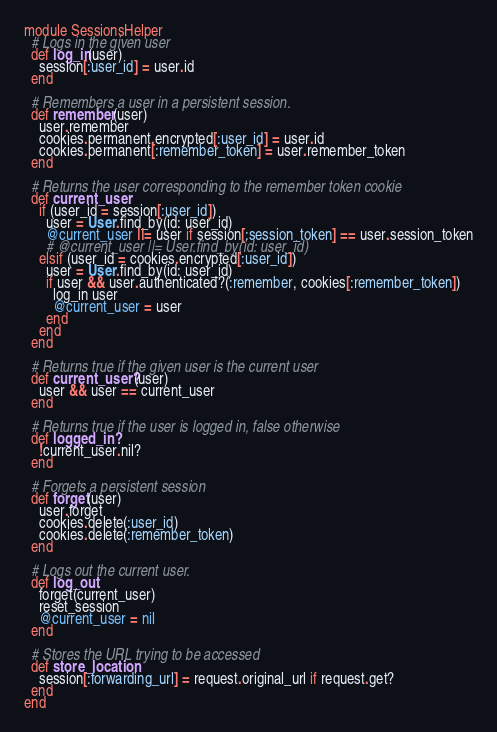<code> <loc_0><loc_0><loc_500><loc_500><_Ruby_>module SessionsHelper
  # Logs in the given user
  def log_in(user)
    session[:user_id] = user.id
  end

  # Remembers a user in a persistent session.
  def remember(user)
    user.remember
    cookies.permanent.encrypted[:user_id] = user.id
    cookies.permanent[:remember_token] = user.remember_token
  end
  
  # Returns the user corresponding to the remember token cookie
  def current_user
    if (user_id = session[:user_id])
      user = User.find_by(id: user_id)
      @current_user ||= user if session[:session_token] == user.session_token
      # @current_user ||= User.find_by(id: user_id)
    elsif (user_id = cookies.encrypted[:user_id])
      user = User.find_by(id: user_id)
      if user && user.authenticated?(:remember, cookies[:remember_token])
        log_in user
        @current_user = user
      end
    end
  end

  # Returns true if the given user is the current user
  def current_user?(user)
    user && user == current_user
  end

  # Returns true if the user is logged in, false otherwise
  def logged_in?
    !current_user.nil?
  end

  # Forgets a persistent session
  def forget(user)
    user.forget
    cookies.delete(:user_id)
    cookies.delete(:remember_token)
  end

  # Logs out the current user.
  def log_out
    forget(current_user)
    reset_session
    @current_user = nil
  end

  # Stores the URL trying to be accessed
  def store_location
    session[:forwarding_url] = request.original_url if request.get?
  end
end
</code> 